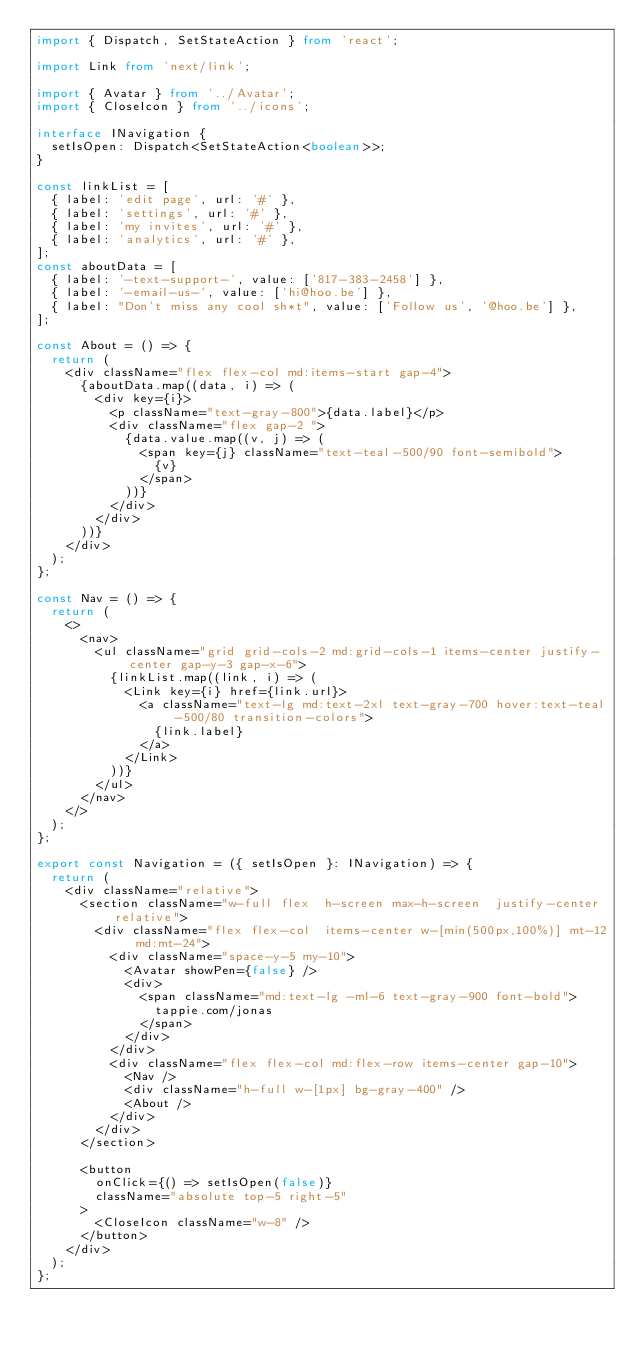<code> <loc_0><loc_0><loc_500><loc_500><_TypeScript_>import { Dispatch, SetStateAction } from 'react';

import Link from 'next/link';

import { Avatar } from '../Avatar';
import { CloseIcon } from '../icons';

interface INavigation {
  setIsOpen: Dispatch<SetStateAction<boolean>>;
}

const linkList = [
  { label: 'edit page', url: '#' },
  { label: 'settings', url: '#' },
  { label: 'my invites', url: '#' },
  { label: 'analytics', url: '#' },
];
const aboutData = [
  { label: '-text-support-', value: ['817-383-2458'] },
  { label: '-email-us-', value: ['hi@hoo.be'] },
  { label: "Don't miss any cool sh*t", value: ['Follow us', '@hoo.be'] },
];

const About = () => {
  return (
    <div className="flex flex-col md:items-start gap-4">
      {aboutData.map((data, i) => (
        <div key={i}>
          <p className="text-gray-800">{data.label}</p>
          <div className="flex gap-2 ">
            {data.value.map((v, j) => (
              <span key={j} className="text-teal-500/90 font-semibold">
                {v}
              </span>
            ))}
          </div>
        </div>
      ))}
    </div>
  );
};

const Nav = () => {
  return (
    <>
      <nav>
        <ul className="grid grid-cols-2 md:grid-cols-1 items-center justify-center gap-y-3 gap-x-6">
          {linkList.map((link, i) => (
            <Link key={i} href={link.url}>
              <a className="text-lg md:text-2xl text-gray-700 hover:text-teal-500/80 transition-colors">
                {link.label}
              </a>
            </Link>
          ))}
        </ul>
      </nav>
    </>
  );
};

export const Navigation = ({ setIsOpen }: INavigation) => {
  return (
    <div className="relative">
      <section className="w-full flex  h-screen max-h-screen  justify-center relative">
        <div className="flex flex-col  items-center w-[min(500px,100%)] mt-12 md:mt-24">
          <div className="space-y-5 my-10">
            <Avatar showPen={false} />
            <div>
              <span className="md:text-lg -ml-6 text-gray-900 font-bold">
                tappie.com/jonas
              </span>
            </div>
          </div>
          <div className="flex flex-col md:flex-row items-center gap-10">
            <Nav />
            <div className="h-full w-[1px] bg-gray-400" />
            <About />
          </div>
        </div>
      </section>

      <button
        onClick={() => setIsOpen(false)}
        className="absolute top-5 right-5"
      >
        <CloseIcon className="w-8" />
      </button>
    </div>
  );
};
</code> 